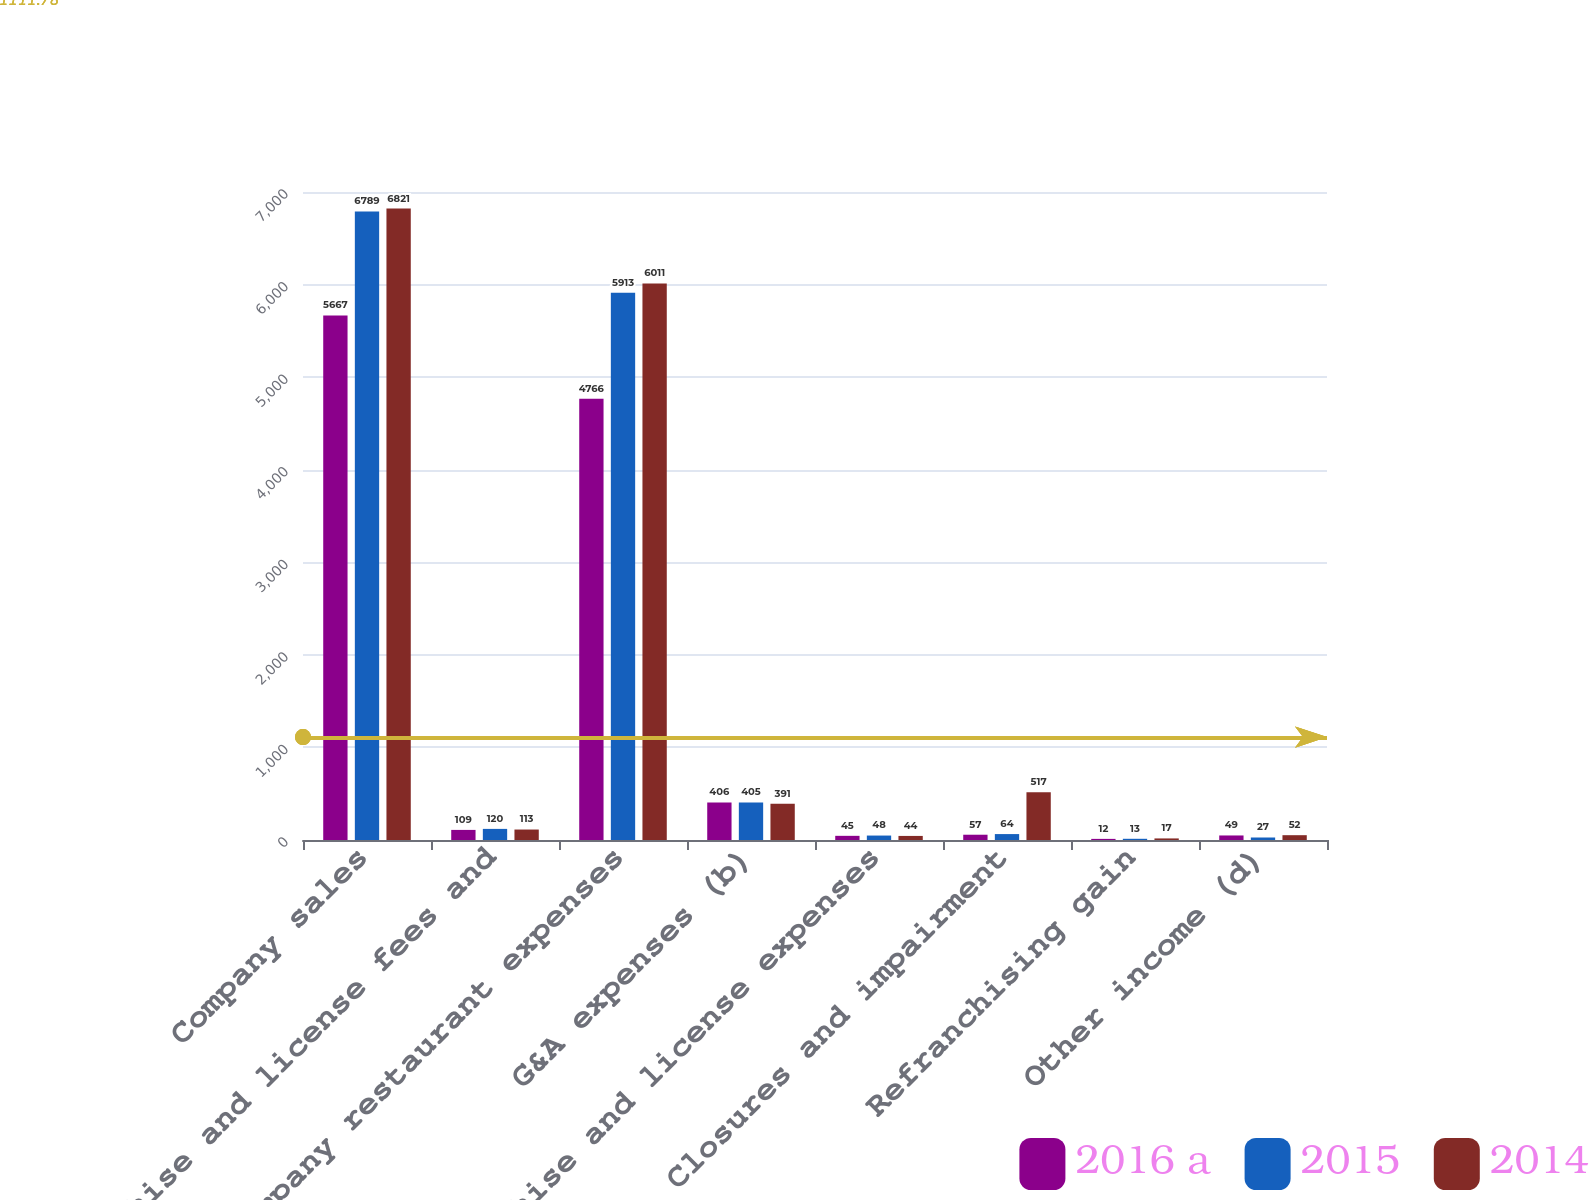Convert chart to OTSL. <chart><loc_0><loc_0><loc_500><loc_500><stacked_bar_chart><ecel><fcel>Company sales<fcel>Franchise and license fees and<fcel>Company restaurant expenses<fcel>G&A expenses (b)<fcel>Franchise and license expenses<fcel>Closures and impairment<fcel>Refranchising gain<fcel>Other income (d)<nl><fcel>2016 a<fcel>5667<fcel>109<fcel>4766<fcel>406<fcel>45<fcel>57<fcel>12<fcel>49<nl><fcel>2015<fcel>6789<fcel>120<fcel>5913<fcel>405<fcel>48<fcel>64<fcel>13<fcel>27<nl><fcel>2014<fcel>6821<fcel>113<fcel>6011<fcel>391<fcel>44<fcel>517<fcel>17<fcel>52<nl></chart> 